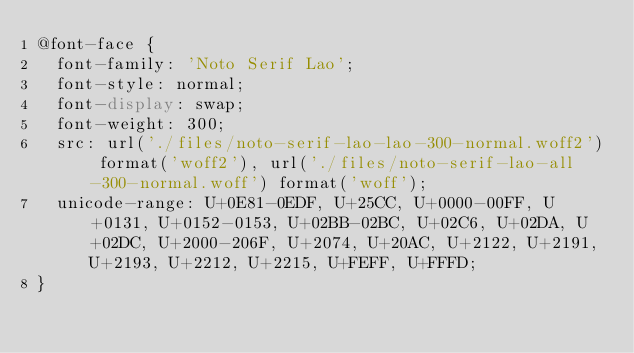Convert code to text. <code><loc_0><loc_0><loc_500><loc_500><_CSS_>@font-face {
  font-family: 'Noto Serif Lao';
  font-style: normal;
  font-display: swap;
  font-weight: 300;
  src: url('./files/noto-serif-lao-lao-300-normal.woff2') format('woff2'), url('./files/noto-serif-lao-all-300-normal.woff') format('woff');
  unicode-range: U+0E81-0EDF, U+25CC, U+0000-00FF, U+0131, U+0152-0153, U+02BB-02BC, U+02C6, U+02DA, U+02DC, U+2000-206F, U+2074, U+20AC, U+2122, U+2191, U+2193, U+2212, U+2215, U+FEFF, U+FFFD;
}
</code> 